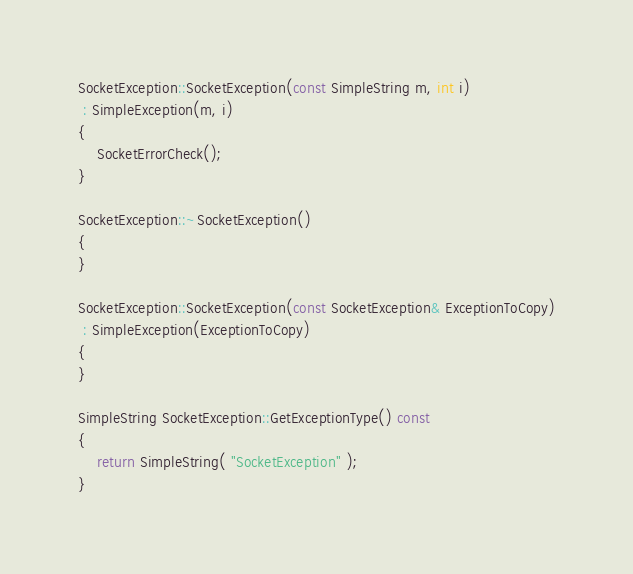Convert code to text. <code><loc_0><loc_0><loc_500><loc_500><_C++_>SocketException::SocketException(const SimpleString m, int i)
 : SimpleException(m, i)
{
	SocketErrorCheck();
}

SocketException::~SocketException()
{
}

SocketException::SocketException(const SocketException& ExceptionToCopy)
 : SimpleException(ExceptionToCopy)
{
}

SimpleString SocketException::GetExceptionType() const
{
	return SimpleString( "SocketException" );
}

</code> 